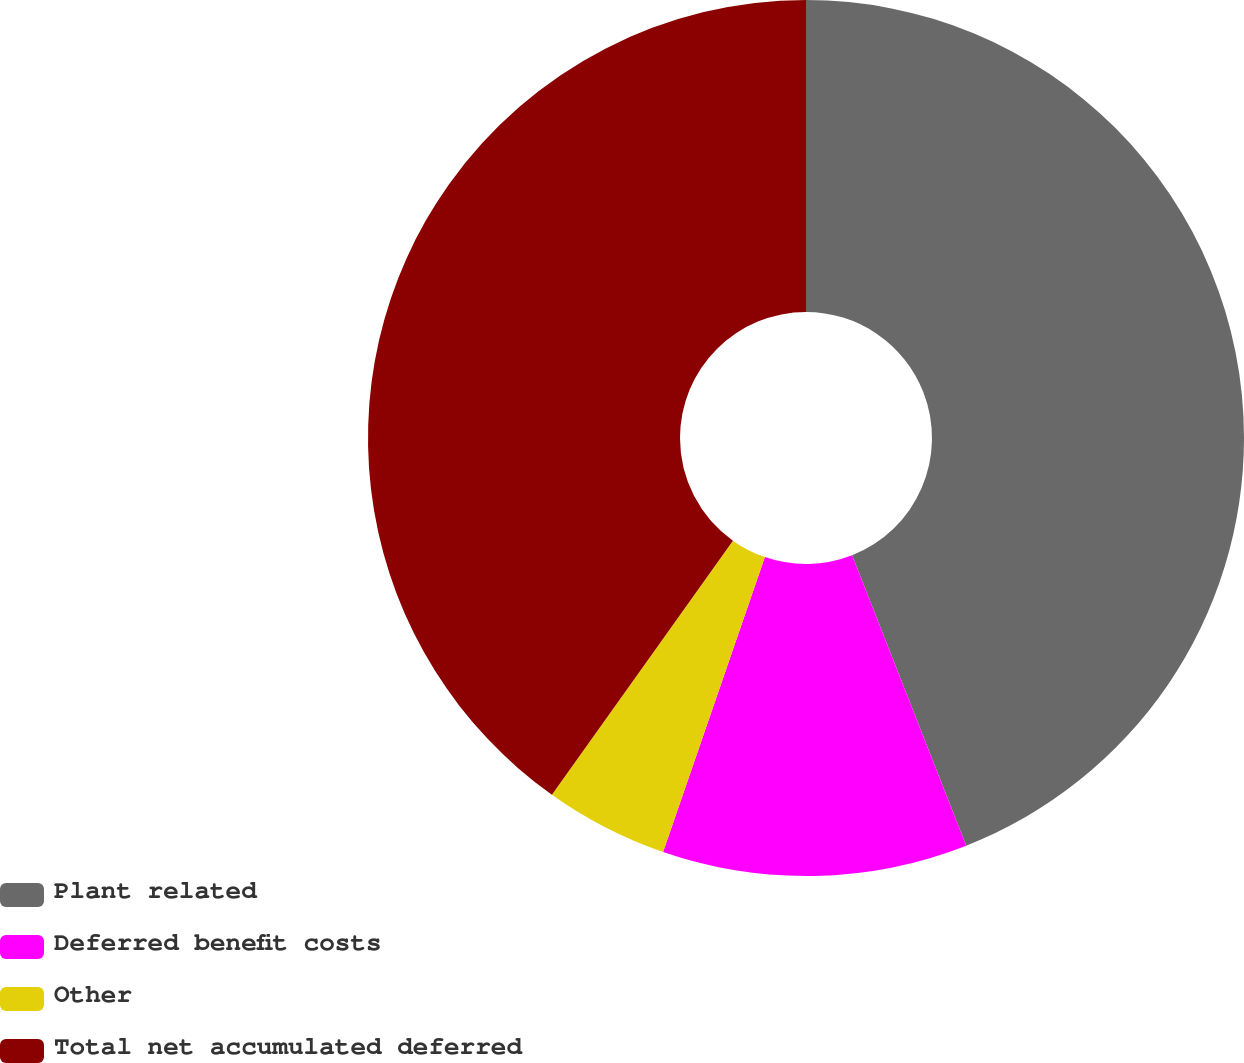Convert chart. <chart><loc_0><loc_0><loc_500><loc_500><pie_chart><fcel>Plant related<fcel>Deferred benefit costs<fcel>Other<fcel>Total net accumulated deferred<nl><fcel>44.04%<fcel>11.25%<fcel>4.56%<fcel>40.15%<nl></chart> 